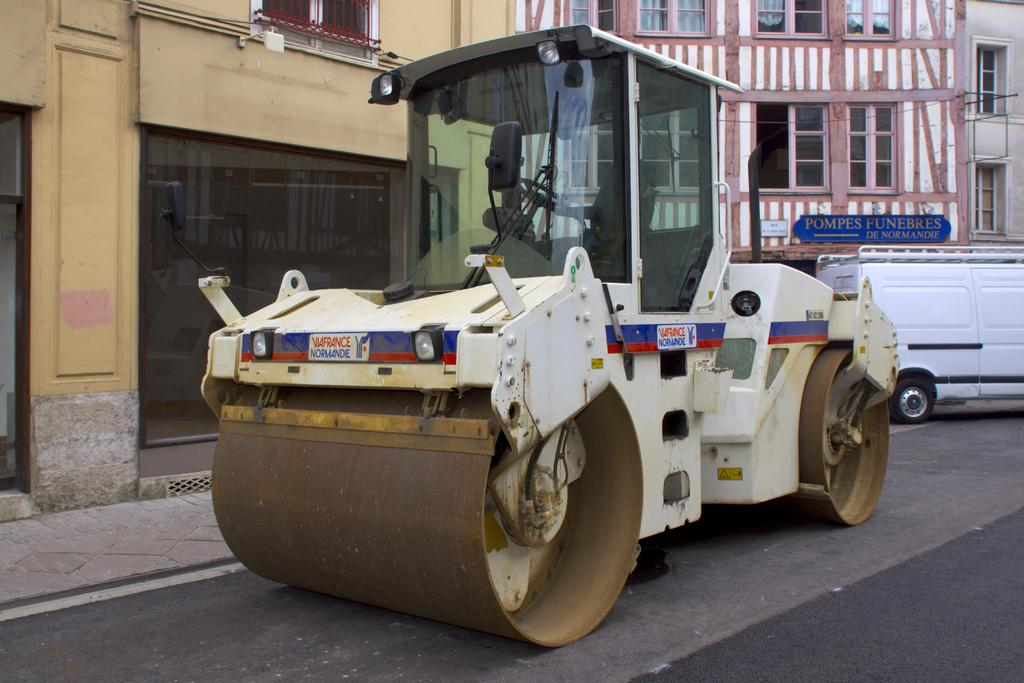What type of machinery is present in the image? There is a road roller in the image. What else can be seen on the road in the image? There is a vehicle on the road in the image. What can be seen in the background of the image? There are buildings with windows in the background of the image. What type of doors are on the buildings in the background? There are glass doors on the buildings in the background of the image. Is there any signage on the buildings in the background? Yes, there is a name board on one of the buildings in the background of the image. Can you see any stars in the image? There are no stars visible in the image. Is there a cemetery present in the image? There is no cemetery present in the image. 